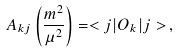Convert formula to latex. <formula><loc_0><loc_0><loc_500><loc_500>A _ { k j } \left ( \frac { m ^ { 2 } } { \mu ^ { 2 } } \right ) = < j | O _ { k } | j > \, ,</formula> 